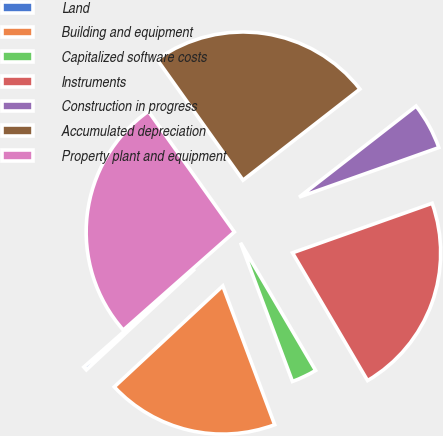Convert chart to OTSL. <chart><loc_0><loc_0><loc_500><loc_500><pie_chart><fcel>Land<fcel>Building and equipment<fcel>Capitalized software costs<fcel>Instruments<fcel>Construction in progress<fcel>Accumulated depreciation<fcel>Property plant and equipment<nl><fcel>0.41%<fcel>18.77%<fcel>2.76%<fcel>21.97%<fcel>5.11%<fcel>24.32%<fcel>26.67%<nl></chart> 